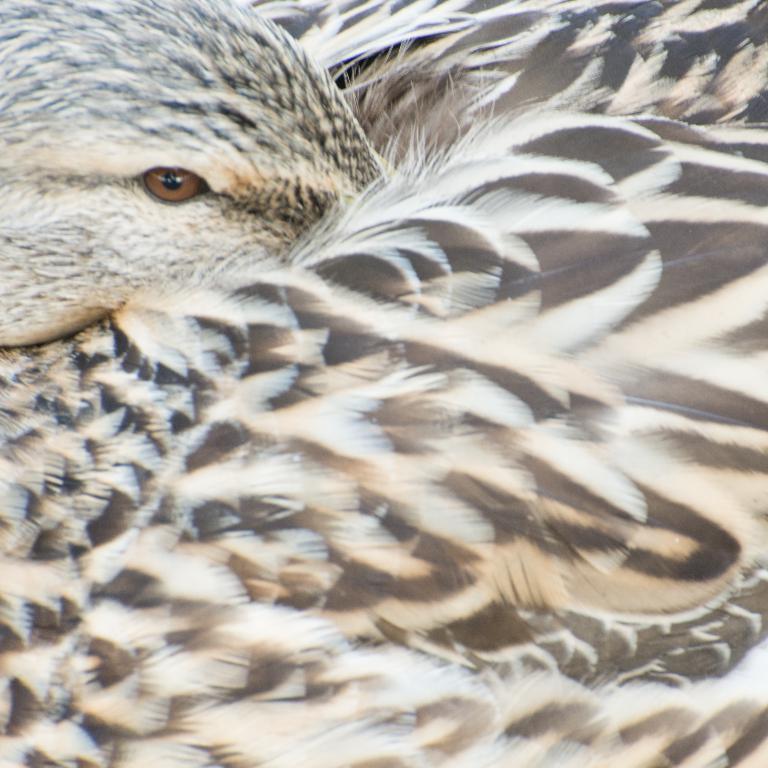Describe this image in one or two sentences. In this image we can see there is a bird. 